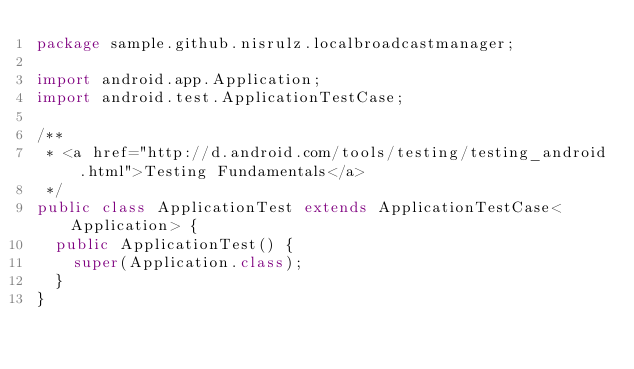Convert code to text. <code><loc_0><loc_0><loc_500><loc_500><_Java_>package sample.github.nisrulz.localbroadcastmanager;

import android.app.Application;
import android.test.ApplicationTestCase;

/**
 * <a href="http://d.android.com/tools/testing/testing_android.html">Testing Fundamentals</a>
 */
public class ApplicationTest extends ApplicationTestCase<Application> {
  public ApplicationTest() {
    super(Application.class);
  }
}</code> 